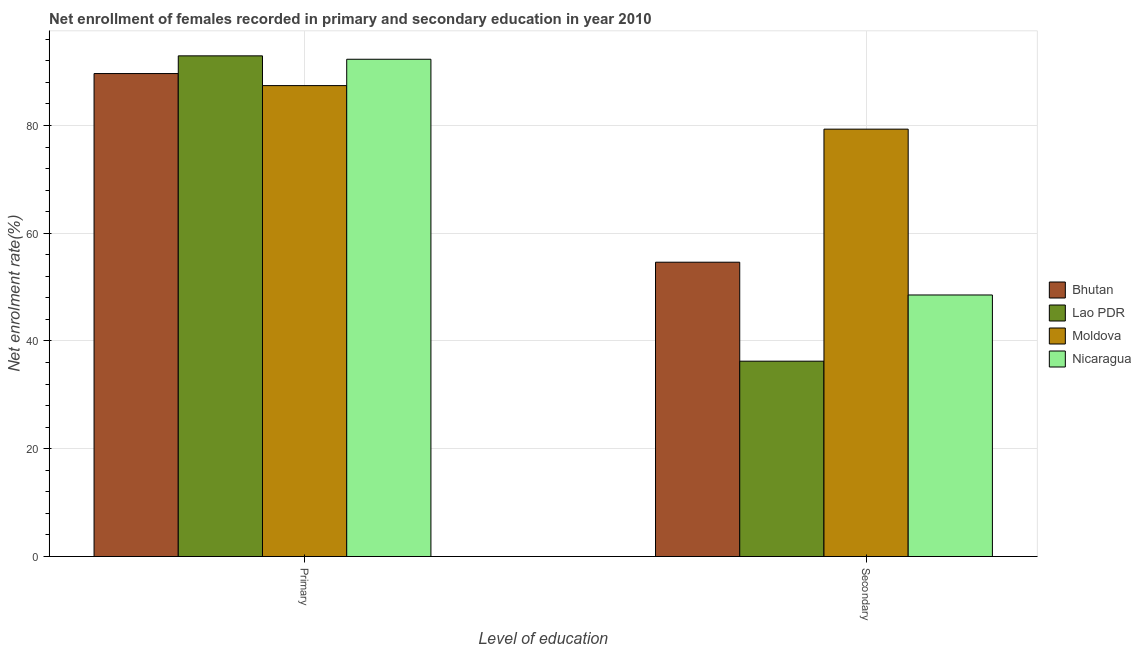How many different coloured bars are there?
Your answer should be very brief. 4. Are the number of bars on each tick of the X-axis equal?
Ensure brevity in your answer.  Yes. How many bars are there on the 1st tick from the right?
Offer a very short reply. 4. What is the label of the 1st group of bars from the left?
Ensure brevity in your answer.  Primary. What is the enrollment rate in primary education in Nicaragua?
Make the answer very short. 92.29. Across all countries, what is the maximum enrollment rate in secondary education?
Give a very brief answer. 79.32. Across all countries, what is the minimum enrollment rate in secondary education?
Make the answer very short. 36.25. In which country was the enrollment rate in secondary education maximum?
Keep it short and to the point. Moldova. In which country was the enrollment rate in primary education minimum?
Offer a very short reply. Moldova. What is the total enrollment rate in secondary education in the graph?
Offer a very short reply. 218.73. What is the difference between the enrollment rate in secondary education in Lao PDR and that in Bhutan?
Give a very brief answer. -18.37. What is the difference between the enrollment rate in secondary education in Moldova and the enrollment rate in primary education in Bhutan?
Your answer should be very brief. -10.32. What is the average enrollment rate in secondary education per country?
Offer a terse response. 54.68. What is the difference between the enrollment rate in secondary education and enrollment rate in primary education in Nicaragua?
Provide a succinct answer. -43.75. In how many countries, is the enrollment rate in primary education greater than 48 %?
Your answer should be very brief. 4. What is the ratio of the enrollment rate in secondary education in Bhutan to that in Lao PDR?
Offer a very short reply. 1.51. In how many countries, is the enrollment rate in primary education greater than the average enrollment rate in primary education taken over all countries?
Give a very brief answer. 2. What does the 4th bar from the left in Primary represents?
Your answer should be compact. Nicaragua. What does the 4th bar from the right in Secondary represents?
Offer a very short reply. Bhutan. Are all the bars in the graph horizontal?
Give a very brief answer. No. What is the difference between two consecutive major ticks on the Y-axis?
Keep it short and to the point. 20. Are the values on the major ticks of Y-axis written in scientific E-notation?
Your response must be concise. No. Where does the legend appear in the graph?
Ensure brevity in your answer.  Center right. How are the legend labels stacked?
Offer a terse response. Vertical. What is the title of the graph?
Your response must be concise. Net enrollment of females recorded in primary and secondary education in year 2010. What is the label or title of the X-axis?
Offer a terse response. Level of education. What is the label or title of the Y-axis?
Offer a terse response. Net enrolment rate(%). What is the Net enrolment rate(%) in Bhutan in Primary?
Keep it short and to the point. 89.63. What is the Net enrolment rate(%) in Lao PDR in Primary?
Give a very brief answer. 92.92. What is the Net enrolment rate(%) of Moldova in Primary?
Give a very brief answer. 87.4. What is the Net enrolment rate(%) in Nicaragua in Primary?
Provide a succinct answer. 92.29. What is the Net enrolment rate(%) of Bhutan in Secondary?
Ensure brevity in your answer.  54.62. What is the Net enrolment rate(%) of Lao PDR in Secondary?
Your answer should be very brief. 36.25. What is the Net enrolment rate(%) of Moldova in Secondary?
Make the answer very short. 79.32. What is the Net enrolment rate(%) of Nicaragua in Secondary?
Your answer should be compact. 48.54. Across all Level of education, what is the maximum Net enrolment rate(%) in Bhutan?
Provide a short and direct response. 89.63. Across all Level of education, what is the maximum Net enrolment rate(%) in Lao PDR?
Make the answer very short. 92.92. Across all Level of education, what is the maximum Net enrolment rate(%) of Moldova?
Your response must be concise. 87.4. Across all Level of education, what is the maximum Net enrolment rate(%) of Nicaragua?
Ensure brevity in your answer.  92.29. Across all Level of education, what is the minimum Net enrolment rate(%) in Bhutan?
Keep it short and to the point. 54.62. Across all Level of education, what is the minimum Net enrolment rate(%) in Lao PDR?
Make the answer very short. 36.25. Across all Level of education, what is the minimum Net enrolment rate(%) in Moldova?
Keep it short and to the point. 79.32. Across all Level of education, what is the minimum Net enrolment rate(%) of Nicaragua?
Offer a terse response. 48.54. What is the total Net enrolment rate(%) of Bhutan in the graph?
Ensure brevity in your answer.  144.26. What is the total Net enrolment rate(%) in Lao PDR in the graph?
Your response must be concise. 129.17. What is the total Net enrolment rate(%) in Moldova in the graph?
Provide a short and direct response. 166.72. What is the total Net enrolment rate(%) in Nicaragua in the graph?
Provide a succinct answer. 140.83. What is the difference between the Net enrolment rate(%) of Bhutan in Primary and that in Secondary?
Your answer should be compact. 35.01. What is the difference between the Net enrolment rate(%) of Lao PDR in Primary and that in Secondary?
Ensure brevity in your answer.  56.67. What is the difference between the Net enrolment rate(%) of Moldova in Primary and that in Secondary?
Your answer should be very brief. 8.08. What is the difference between the Net enrolment rate(%) in Nicaragua in Primary and that in Secondary?
Offer a very short reply. 43.75. What is the difference between the Net enrolment rate(%) in Bhutan in Primary and the Net enrolment rate(%) in Lao PDR in Secondary?
Offer a terse response. 53.38. What is the difference between the Net enrolment rate(%) in Bhutan in Primary and the Net enrolment rate(%) in Moldova in Secondary?
Give a very brief answer. 10.32. What is the difference between the Net enrolment rate(%) of Bhutan in Primary and the Net enrolment rate(%) of Nicaragua in Secondary?
Offer a very short reply. 41.09. What is the difference between the Net enrolment rate(%) of Lao PDR in Primary and the Net enrolment rate(%) of Moldova in Secondary?
Your answer should be very brief. 13.6. What is the difference between the Net enrolment rate(%) in Lao PDR in Primary and the Net enrolment rate(%) in Nicaragua in Secondary?
Your response must be concise. 44.38. What is the difference between the Net enrolment rate(%) in Moldova in Primary and the Net enrolment rate(%) in Nicaragua in Secondary?
Your answer should be compact. 38.86. What is the average Net enrolment rate(%) of Bhutan per Level of education?
Give a very brief answer. 72.13. What is the average Net enrolment rate(%) in Lao PDR per Level of education?
Ensure brevity in your answer.  64.59. What is the average Net enrolment rate(%) in Moldova per Level of education?
Offer a terse response. 83.36. What is the average Net enrolment rate(%) in Nicaragua per Level of education?
Ensure brevity in your answer.  70.41. What is the difference between the Net enrolment rate(%) of Bhutan and Net enrolment rate(%) of Lao PDR in Primary?
Make the answer very short. -3.29. What is the difference between the Net enrolment rate(%) of Bhutan and Net enrolment rate(%) of Moldova in Primary?
Your answer should be compact. 2.23. What is the difference between the Net enrolment rate(%) of Bhutan and Net enrolment rate(%) of Nicaragua in Primary?
Your answer should be compact. -2.65. What is the difference between the Net enrolment rate(%) of Lao PDR and Net enrolment rate(%) of Moldova in Primary?
Keep it short and to the point. 5.52. What is the difference between the Net enrolment rate(%) in Lao PDR and Net enrolment rate(%) in Nicaragua in Primary?
Offer a very short reply. 0.63. What is the difference between the Net enrolment rate(%) in Moldova and Net enrolment rate(%) in Nicaragua in Primary?
Keep it short and to the point. -4.89. What is the difference between the Net enrolment rate(%) in Bhutan and Net enrolment rate(%) in Lao PDR in Secondary?
Give a very brief answer. 18.37. What is the difference between the Net enrolment rate(%) of Bhutan and Net enrolment rate(%) of Moldova in Secondary?
Offer a very short reply. -24.69. What is the difference between the Net enrolment rate(%) in Bhutan and Net enrolment rate(%) in Nicaragua in Secondary?
Your answer should be very brief. 6.08. What is the difference between the Net enrolment rate(%) of Lao PDR and Net enrolment rate(%) of Moldova in Secondary?
Provide a succinct answer. -43.06. What is the difference between the Net enrolment rate(%) in Lao PDR and Net enrolment rate(%) in Nicaragua in Secondary?
Ensure brevity in your answer.  -12.29. What is the difference between the Net enrolment rate(%) of Moldova and Net enrolment rate(%) of Nicaragua in Secondary?
Give a very brief answer. 30.78. What is the ratio of the Net enrolment rate(%) of Bhutan in Primary to that in Secondary?
Offer a terse response. 1.64. What is the ratio of the Net enrolment rate(%) in Lao PDR in Primary to that in Secondary?
Give a very brief answer. 2.56. What is the ratio of the Net enrolment rate(%) of Moldova in Primary to that in Secondary?
Provide a succinct answer. 1.1. What is the ratio of the Net enrolment rate(%) in Nicaragua in Primary to that in Secondary?
Your answer should be very brief. 1.9. What is the difference between the highest and the second highest Net enrolment rate(%) in Bhutan?
Keep it short and to the point. 35.01. What is the difference between the highest and the second highest Net enrolment rate(%) of Lao PDR?
Make the answer very short. 56.67. What is the difference between the highest and the second highest Net enrolment rate(%) of Moldova?
Give a very brief answer. 8.08. What is the difference between the highest and the second highest Net enrolment rate(%) of Nicaragua?
Offer a very short reply. 43.75. What is the difference between the highest and the lowest Net enrolment rate(%) in Bhutan?
Provide a short and direct response. 35.01. What is the difference between the highest and the lowest Net enrolment rate(%) of Lao PDR?
Ensure brevity in your answer.  56.67. What is the difference between the highest and the lowest Net enrolment rate(%) in Moldova?
Give a very brief answer. 8.08. What is the difference between the highest and the lowest Net enrolment rate(%) of Nicaragua?
Your response must be concise. 43.75. 